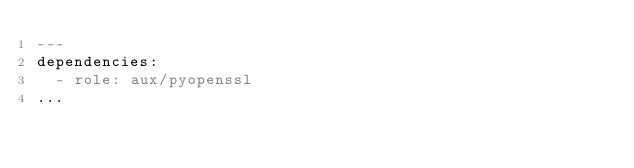<code> <loc_0><loc_0><loc_500><loc_500><_YAML_>---
dependencies:
  - role: aux/pyopenssl
...
</code> 